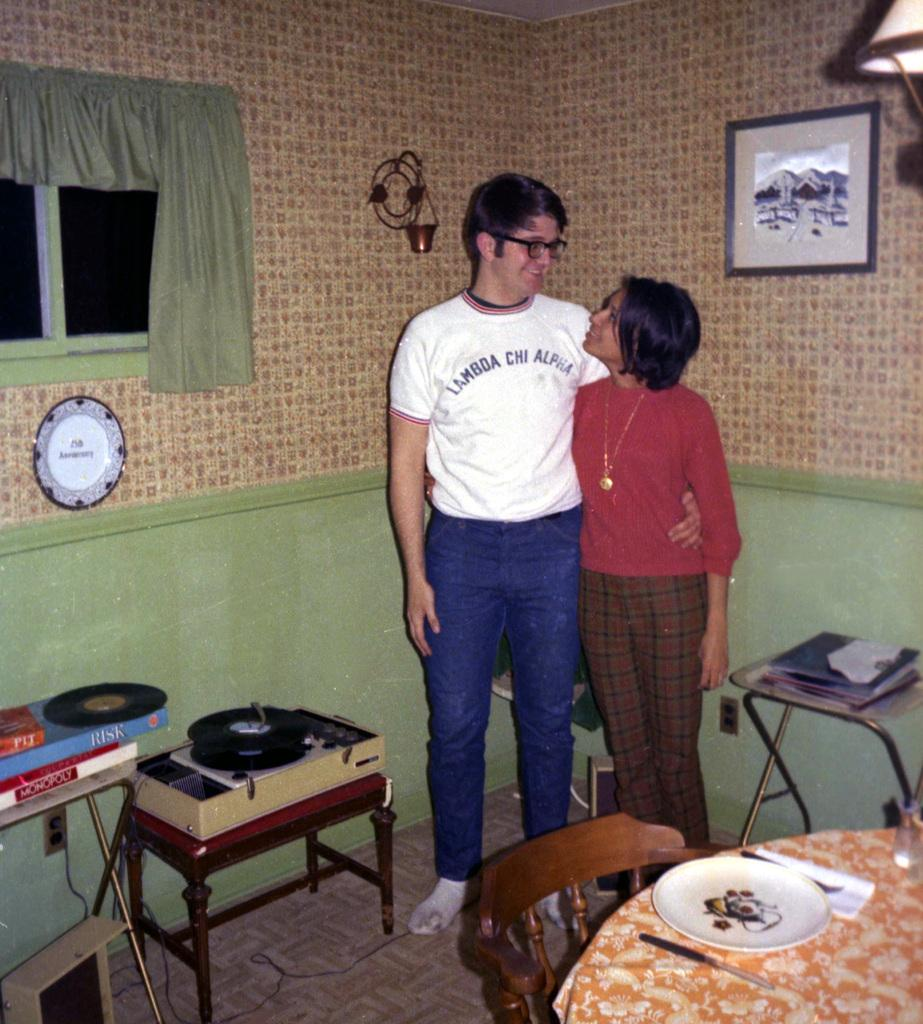<image>
Describe the image concisely. A man and a woman pose for a picture - the man's shirt reads LAMBDA CHI ALPHA 